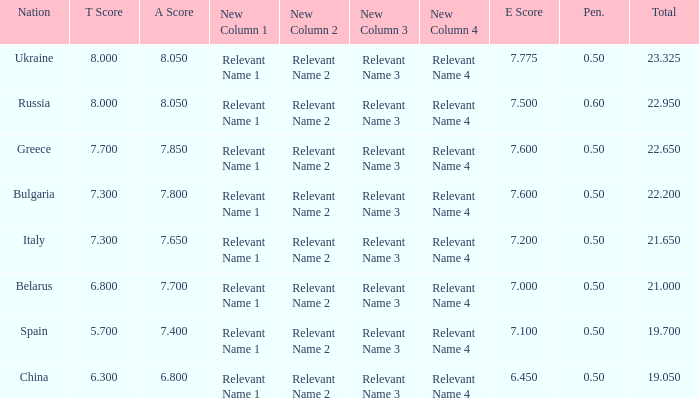What E score has the T score of 8 and a number smaller than 22.95? None. 